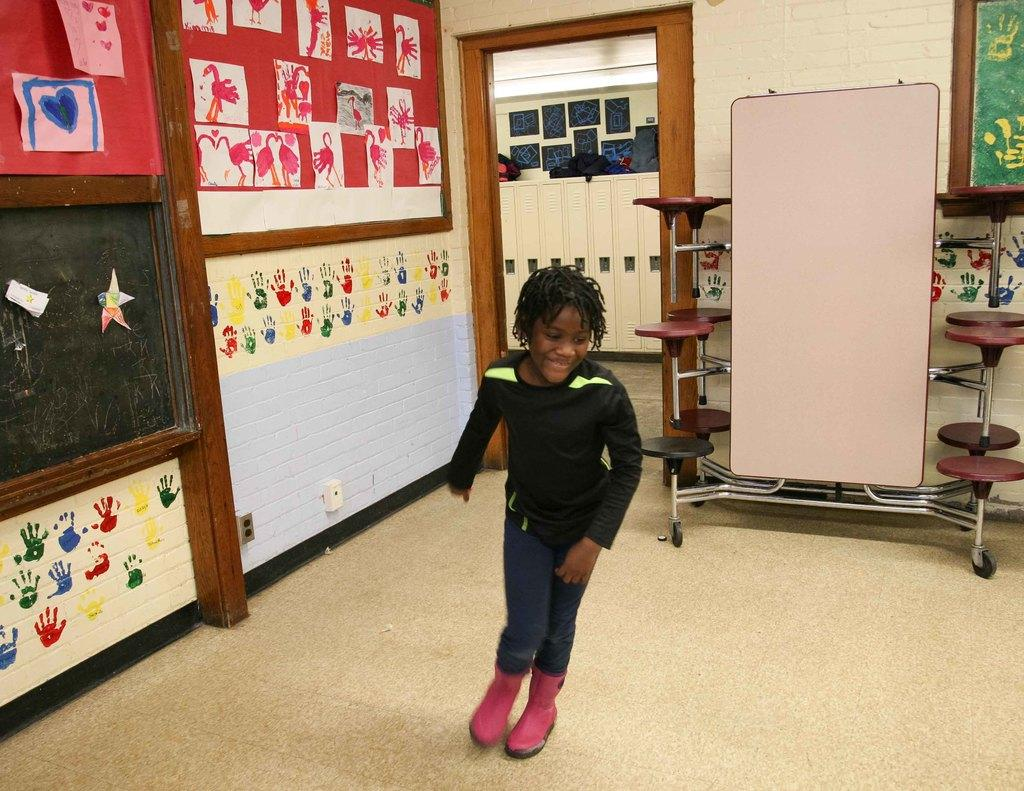Who is the main subject in the image? There is a girl in the center of the image. What can be seen in the background of the image? There is a door and a wall in the background of the image. What is on the wall in the background? There are boards on the wall. What is the surface beneath the girl in the image? There is a floor at the bottom of the image. What type of agreement is being signed by the squirrel in the image? There is no squirrel present in the image, and therefore no agreement being signed. 